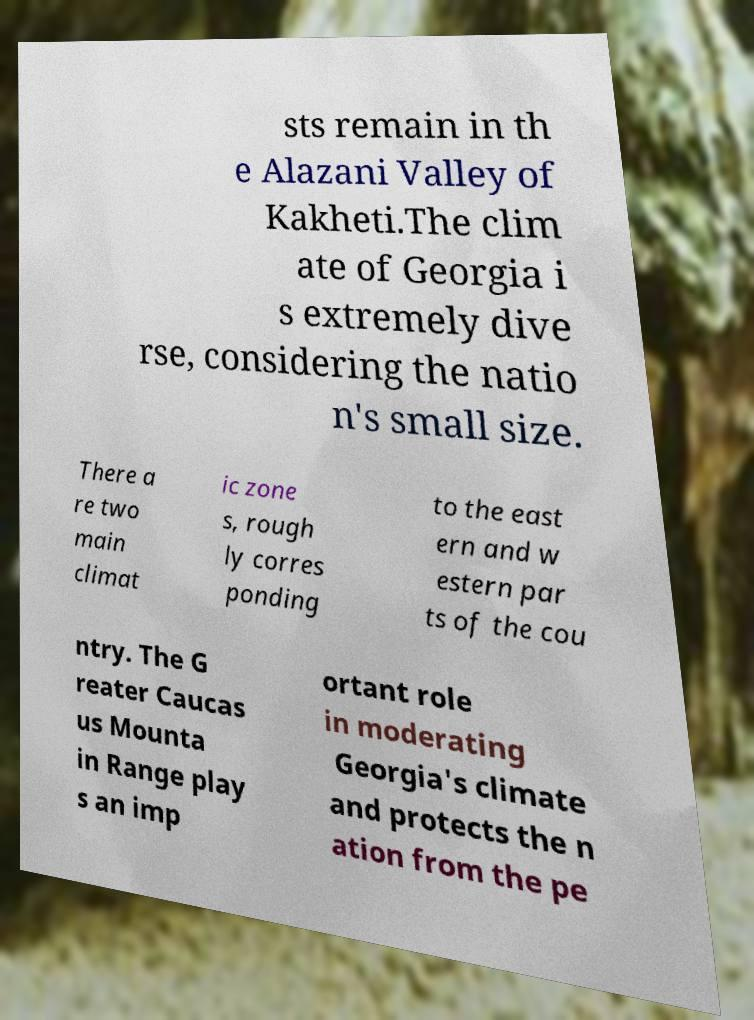Can you accurately transcribe the text from the provided image for me? sts remain in th e Alazani Valley of Kakheti.The clim ate of Georgia i s extremely dive rse, considering the natio n's small size. There a re two main climat ic zone s, rough ly corres ponding to the east ern and w estern par ts of the cou ntry. The G reater Caucas us Mounta in Range play s an imp ortant role in moderating Georgia's climate and protects the n ation from the pe 